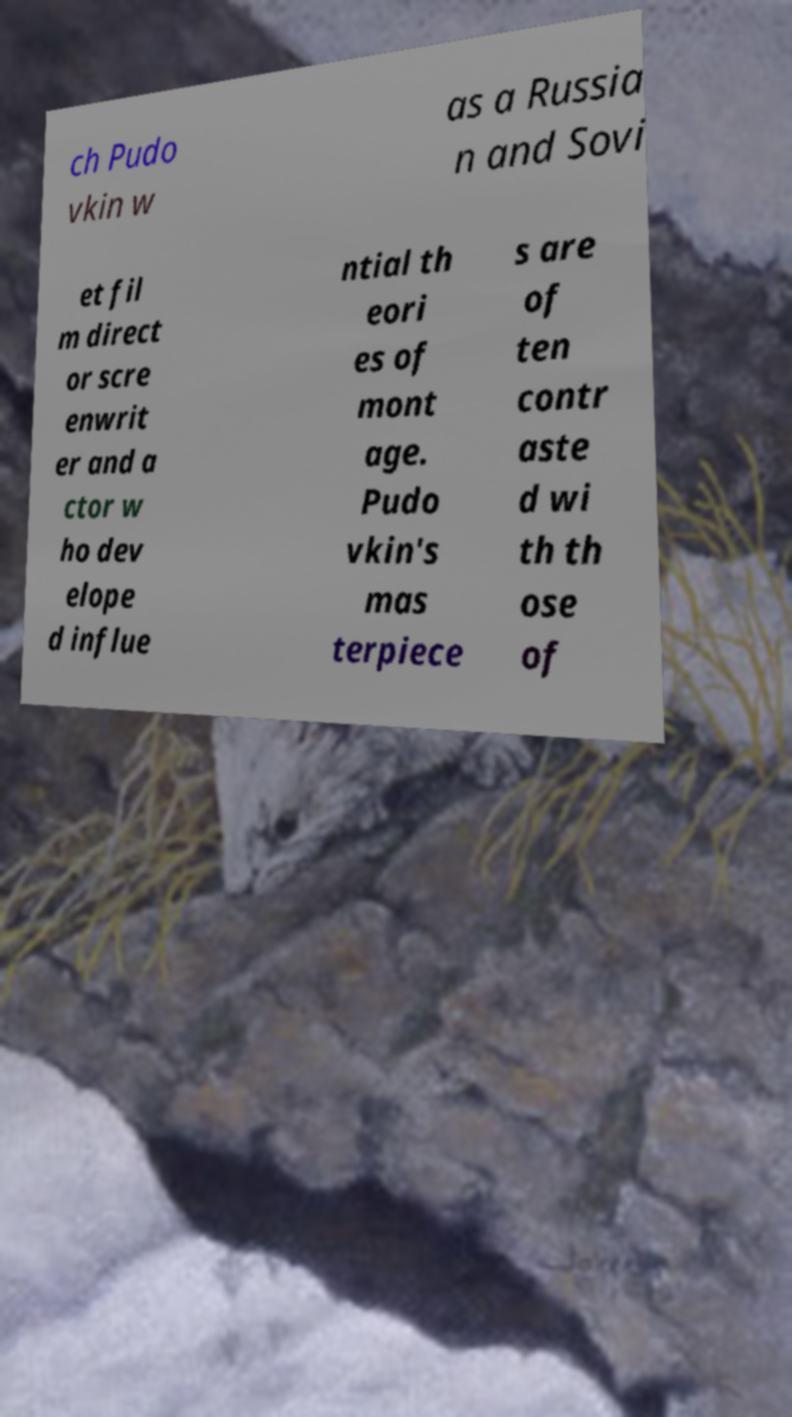I need the written content from this picture converted into text. Can you do that? ch Pudo vkin w as a Russia n and Sovi et fil m direct or scre enwrit er and a ctor w ho dev elope d influe ntial th eori es of mont age. Pudo vkin's mas terpiece s are of ten contr aste d wi th th ose of 